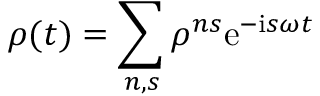Convert formula to latex. <formula><loc_0><loc_0><loc_500><loc_500>\rho ( t ) = \sum _ { n , s } \rho ^ { n s } e ^ { - i s \omega t }</formula> 